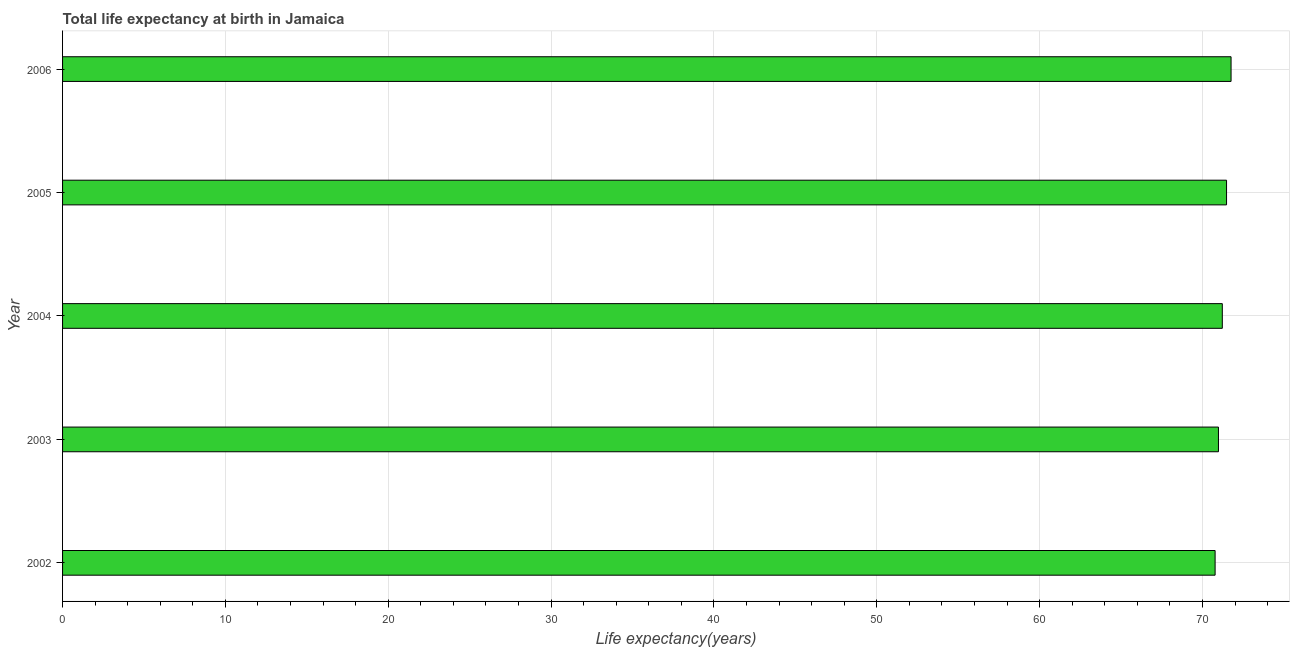Does the graph contain any zero values?
Your answer should be very brief. No. What is the title of the graph?
Give a very brief answer. Total life expectancy at birth in Jamaica. What is the label or title of the X-axis?
Your response must be concise. Life expectancy(years). What is the label or title of the Y-axis?
Offer a terse response. Year. What is the life expectancy at birth in 2004?
Your answer should be very brief. 71.22. Across all years, what is the maximum life expectancy at birth?
Provide a succinct answer. 71.76. Across all years, what is the minimum life expectancy at birth?
Offer a very short reply. 70.78. In which year was the life expectancy at birth maximum?
Your answer should be compact. 2006. In which year was the life expectancy at birth minimum?
Give a very brief answer. 2002. What is the sum of the life expectancy at birth?
Your response must be concise. 356.21. What is the difference between the life expectancy at birth in 2002 and 2004?
Keep it short and to the point. -0.44. What is the average life expectancy at birth per year?
Provide a succinct answer. 71.24. What is the median life expectancy at birth?
Give a very brief answer. 71.22. In how many years, is the life expectancy at birth greater than 64 years?
Give a very brief answer. 5. Do a majority of the years between 2006 and 2005 (inclusive) have life expectancy at birth greater than 46 years?
Provide a short and direct response. No. What is the ratio of the life expectancy at birth in 2002 to that in 2003?
Make the answer very short. 1. Is the life expectancy at birth in 2005 less than that in 2006?
Provide a succinct answer. Yes. Is the difference between the life expectancy at birth in 2005 and 2006 greater than the difference between any two years?
Your response must be concise. No. What is the difference between the highest and the second highest life expectancy at birth?
Make the answer very short. 0.28. What is the difference between the highest and the lowest life expectancy at birth?
Make the answer very short. 0.98. In how many years, is the life expectancy at birth greater than the average life expectancy at birth taken over all years?
Offer a terse response. 2. Are all the bars in the graph horizontal?
Keep it short and to the point. Yes. What is the difference between two consecutive major ticks on the X-axis?
Offer a terse response. 10. What is the Life expectancy(years) of 2002?
Keep it short and to the point. 70.78. What is the Life expectancy(years) in 2003?
Keep it short and to the point. 70.98. What is the Life expectancy(years) of 2004?
Give a very brief answer. 71.22. What is the Life expectancy(years) in 2005?
Provide a short and direct response. 71.48. What is the Life expectancy(years) of 2006?
Provide a succinct answer. 71.76. What is the difference between the Life expectancy(years) in 2002 and 2003?
Your answer should be compact. -0.21. What is the difference between the Life expectancy(years) in 2002 and 2004?
Give a very brief answer. -0.44. What is the difference between the Life expectancy(years) in 2002 and 2005?
Your answer should be very brief. -0.7. What is the difference between the Life expectancy(years) in 2002 and 2006?
Provide a succinct answer. -0.98. What is the difference between the Life expectancy(years) in 2003 and 2004?
Ensure brevity in your answer.  -0.24. What is the difference between the Life expectancy(years) in 2003 and 2005?
Your answer should be compact. -0.5. What is the difference between the Life expectancy(years) in 2003 and 2006?
Offer a very short reply. -0.77. What is the difference between the Life expectancy(years) in 2004 and 2005?
Offer a terse response. -0.26. What is the difference between the Life expectancy(years) in 2004 and 2006?
Offer a very short reply. -0.54. What is the difference between the Life expectancy(years) in 2005 and 2006?
Keep it short and to the point. -0.28. What is the ratio of the Life expectancy(years) in 2002 to that in 2004?
Provide a succinct answer. 0.99. What is the ratio of the Life expectancy(years) in 2003 to that in 2005?
Provide a succinct answer. 0.99. What is the ratio of the Life expectancy(years) in 2003 to that in 2006?
Give a very brief answer. 0.99. What is the ratio of the Life expectancy(years) in 2004 to that in 2005?
Offer a terse response. 1. What is the ratio of the Life expectancy(years) in 2004 to that in 2006?
Your answer should be compact. 0.99. What is the ratio of the Life expectancy(years) in 2005 to that in 2006?
Make the answer very short. 1. 